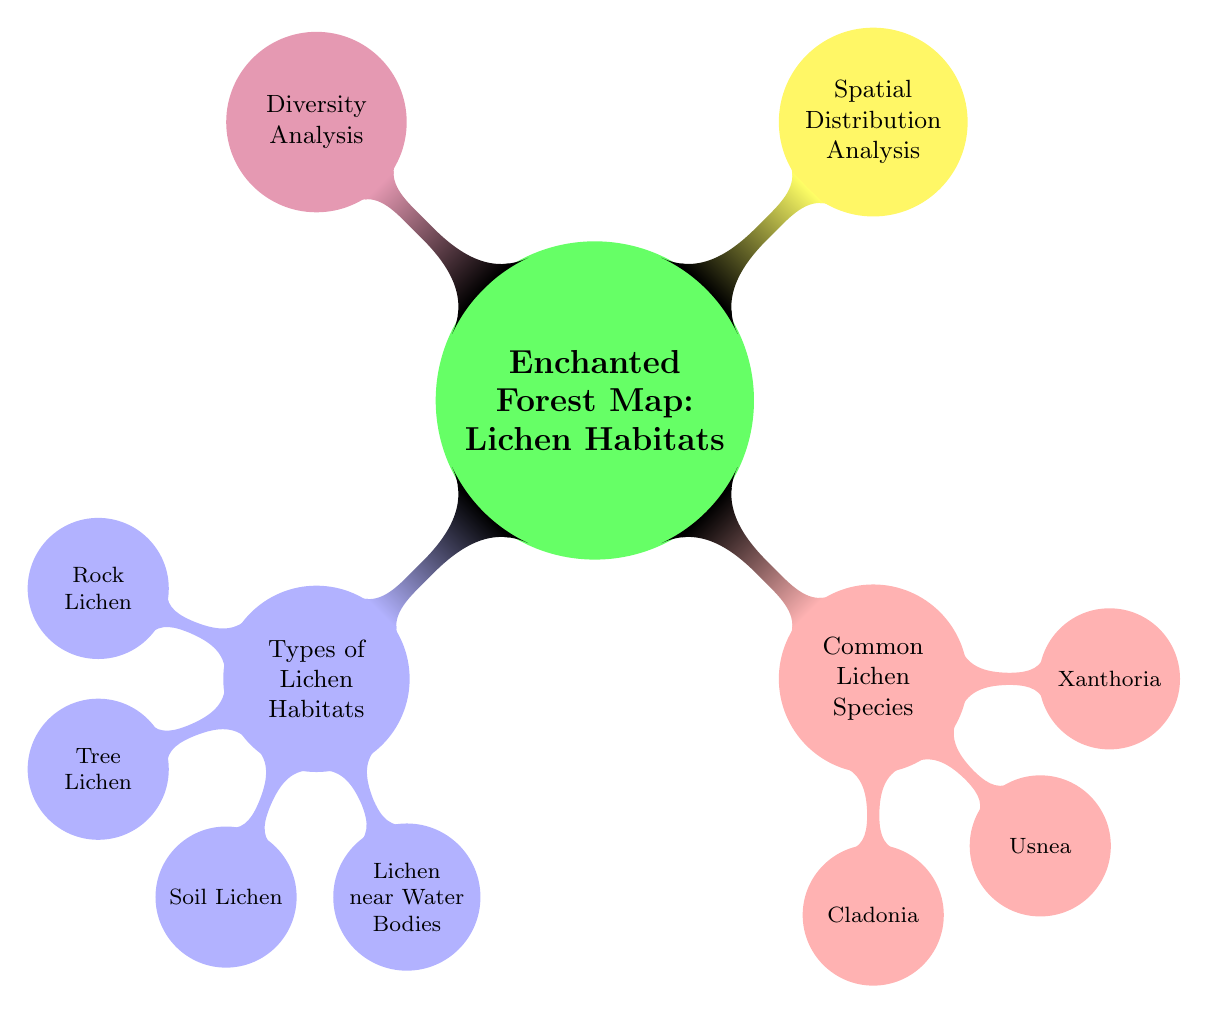What are the types of lichen habitats listed on the diagram? The diagram lists the types of lichen habitats under the "Types of Lichen Habitats" node. There are four child nodes branching from this category, specifically Rock Lichen, Tree Lichen, Soil Lichen, and Lichen near Water Bodies.
Answer: Rock Lichen, Tree Lichen, Soil Lichen, Lichen near Water Bodies How many common lichen species are shown in the diagram? In the diagram, under the "Common Lichen Species" node, there are three child nodes: Cladonia, Usnea, and Xanthoria. Therefore, there are three species listed.
Answer: 3 What color represents the "Spatial Distribution Analysis" node? The "Spatial Distribution Analysis" node is colored yellow, as indicated by its color designation in the diagram.
Answer: Yellow Which lichen species is the first listed under common species? The first lichen species listed under "Common Lichen Species" is Cladonia, as it is the first child node branching from that category.
Answer: Cladonia What do the nodes under "Types of Lichen Habitats" represent in this diagram? The nodes under "Types of Lichen Habitats" represent different environments where lichens can thrive, categorizing them based on their specific habitat types. This includes Rock, Tree, Soil, and Lichen near Water Bodies.
Answer: Different environments for lichens Which two analyses are shown as main branches in this map? The two main branches represented in the diagram are "Spatial Distribution Analysis" and "Diversity Analysis." These are presented as separate child nodes branching from the central concept "Enchanted Forest Map: Lichen Habitats."
Answer: Spatial Distribution Analysis, Diversity Analysis How many total child nodes does the "Common Lichen Species" node have? The "Common Lichen Species" node has three child nodes—namely Cladonia, Usnea, and Xanthoria—indicating the number of species included in this category.
Answer: 3 What is the central theme of this enchanted forest map? The central theme of the map showcased in the diagram revolves around "Lichen Habitats," emphasizing the distribution and diversity of different lichen habitats within an enchanted forest setting.
Answer: Lichen Habitats 